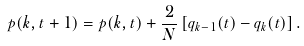Convert formula to latex. <formula><loc_0><loc_0><loc_500><loc_500>p ( k , t + 1 ) = p ( k , t ) + \frac { 2 } { N } \left [ q _ { k - 1 } ( t ) - q _ { k } ( t ) \right ] .</formula> 